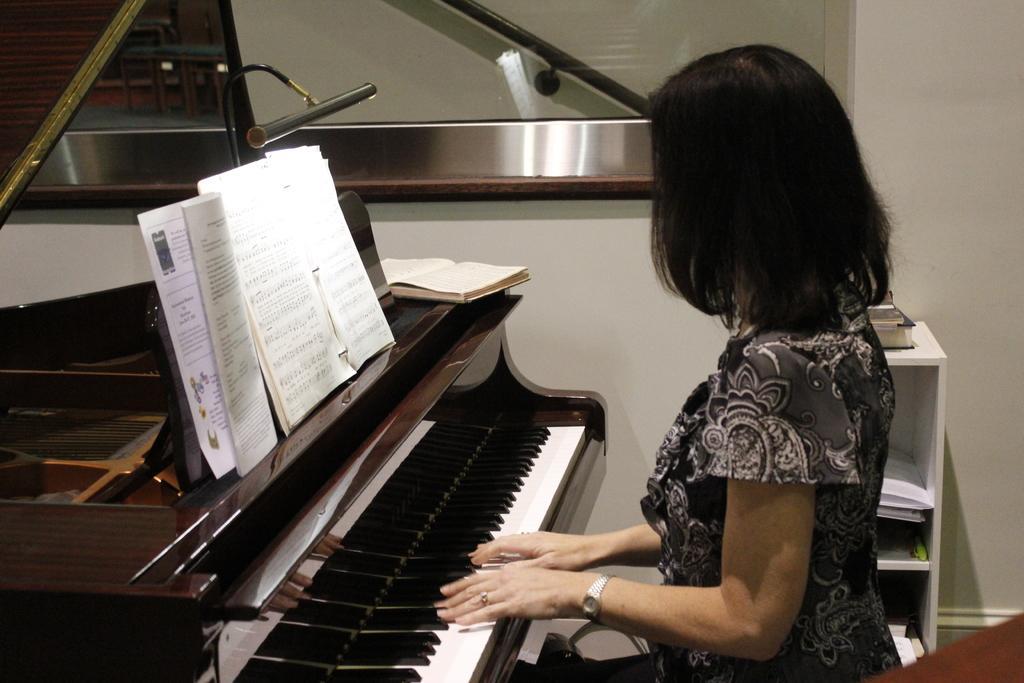Please provide a concise description of this image. In this image I see a woman who kept her hands on the piano and there are books on it. In the background I see the wall and the rack. 